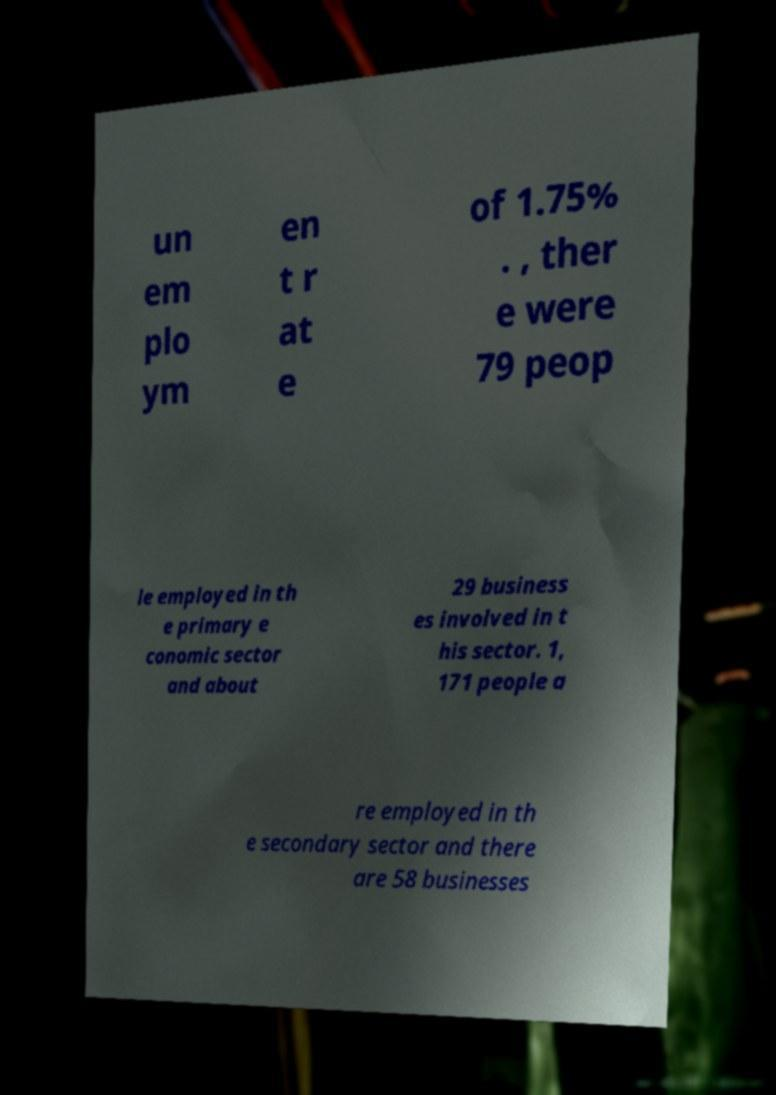I need the written content from this picture converted into text. Can you do that? un em plo ym en t r at e of 1.75% . , ther e were 79 peop le employed in th e primary e conomic sector and about 29 business es involved in t his sector. 1, 171 people a re employed in th e secondary sector and there are 58 businesses 